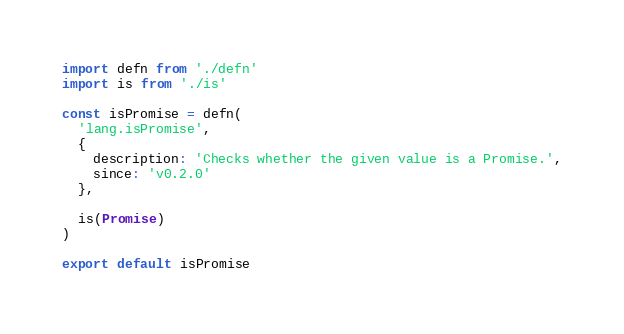Convert code to text. <code><loc_0><loc_0><loc_500><loc_500><_JavaScript_>import defn from './defn'
import is from './is'

const isPromise = defn(
  'lang.isPromise',
  {
    description: 'Checks whether the given value is a Promise.',
    since: 'v0.2.0'
  },

  is(Promise)
)

export default isPromise
</code> 